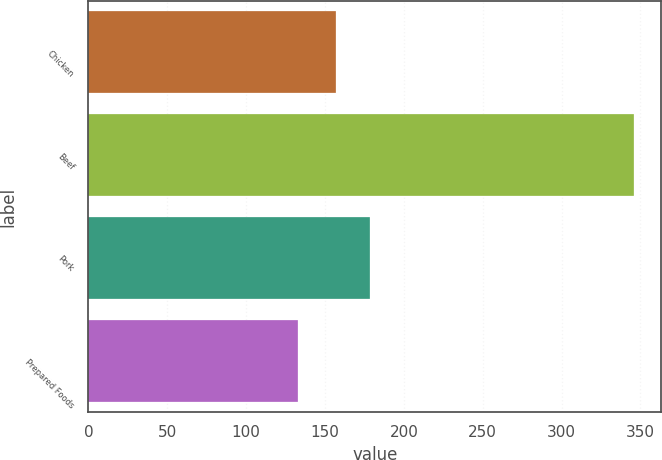Convert chart. <chart><loc_0><loc_0><loc_500><loc_500><bar_chart><fcel>Chicken<fcel>Beef<fcel>Pork<fcel>Prepared Foods<nl><fcel>157<fcel>346<fcel>178.3<fcel>133<nl></chart> 